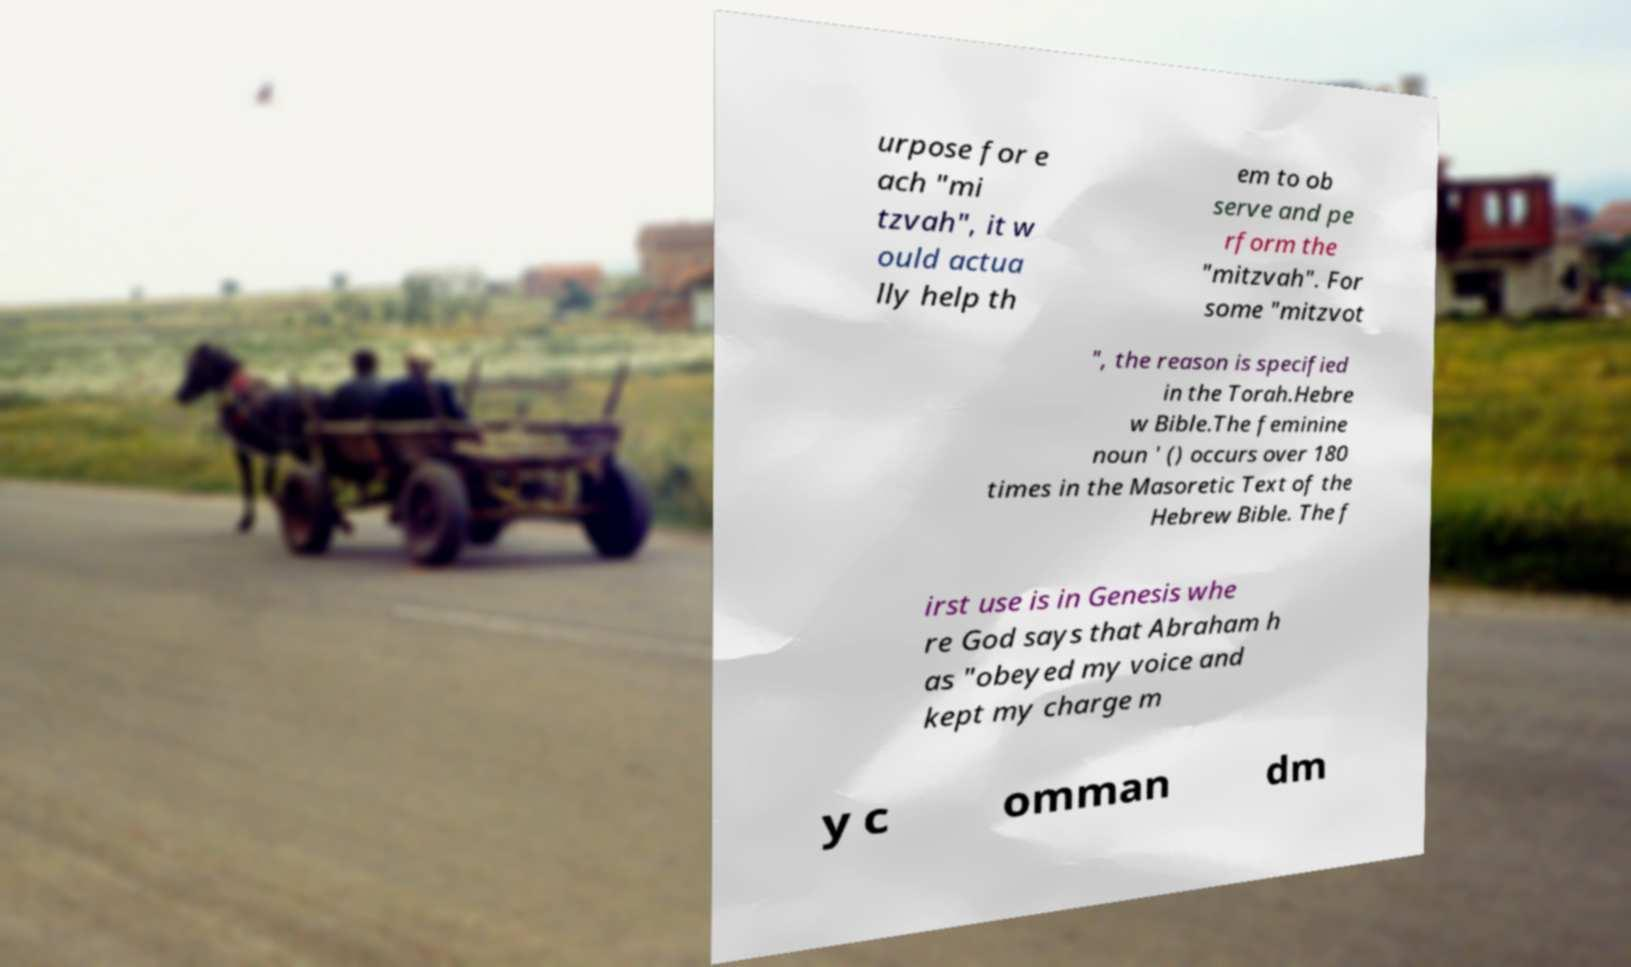Can you accurately transcribe the text from the provided image for me? urpose for e ach "mi tzvah", it w ould actua lly help th em to ob serve and pe rform the "mitzvah". For some "mitzvot ", the reason is specified in the Torah.Hebre w Bible.The feminine noun ' () occurs over 180 times in the Masoretic Text of the Hebrew Bible. The f irst use is in Genesis whe re God says that Abraham h as "obeyed my voice and kept my charge m y c omman dm 